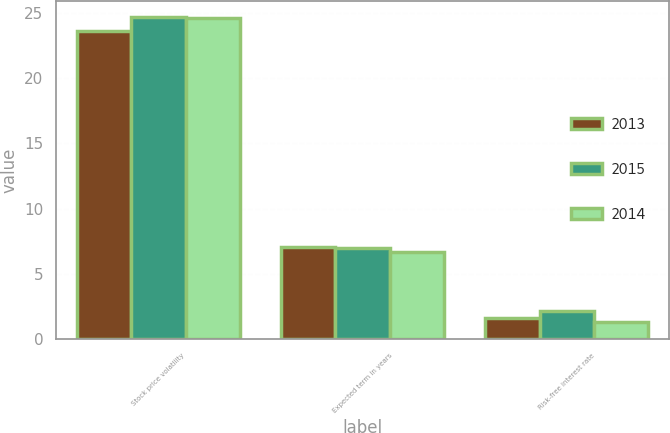Convert chart to OTSL. <chart><loc_0><loc_0><loc_500><loc_500><stacked_bar_chart><ecel><fcel>Stock price volatility<fcel>Expected term in years<fcel>Risk-free interest rate<nl><fcel>2013<fcel>23.62<fcel>7.06<fcel>1.59<nl><fcel>2015<fcel>24.67<fcel>6.95<fcel>2.16<nl><fcel>2014<fcel>24.61<fcel>6.69<fcel>1.31<nl></chart> 